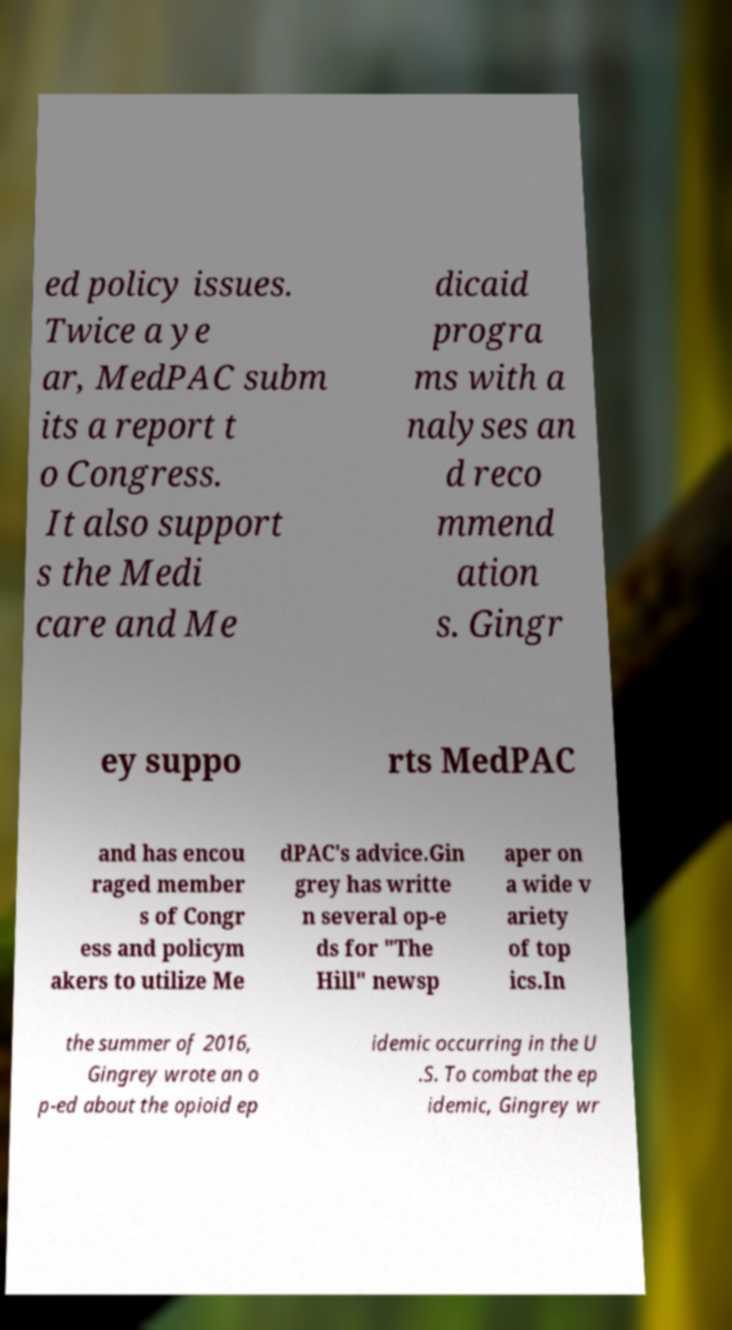Could you assist in decoding the text presented in this image and type it out clearly? ed policy issues. Twice a ye ar, MedPAC subm its a report t o Congress. It also support s the Medi care and Me dicaid progra ms with a nalyses an d reco mmend ation s. Gingr ey suppo rts MedPAC and has encou raged member s of Congr ess and policym akers to utilize Me dPAC's advice.Gin grey has writte n several op-e ds for "The Hill" newsp aper on a wide v ariety of top ics.In the summer of 2016, Gingrey wrote an o p-ed about the opioid ep idemic occurring in the U .S. To combat the ep idemic, Gingrey wr 